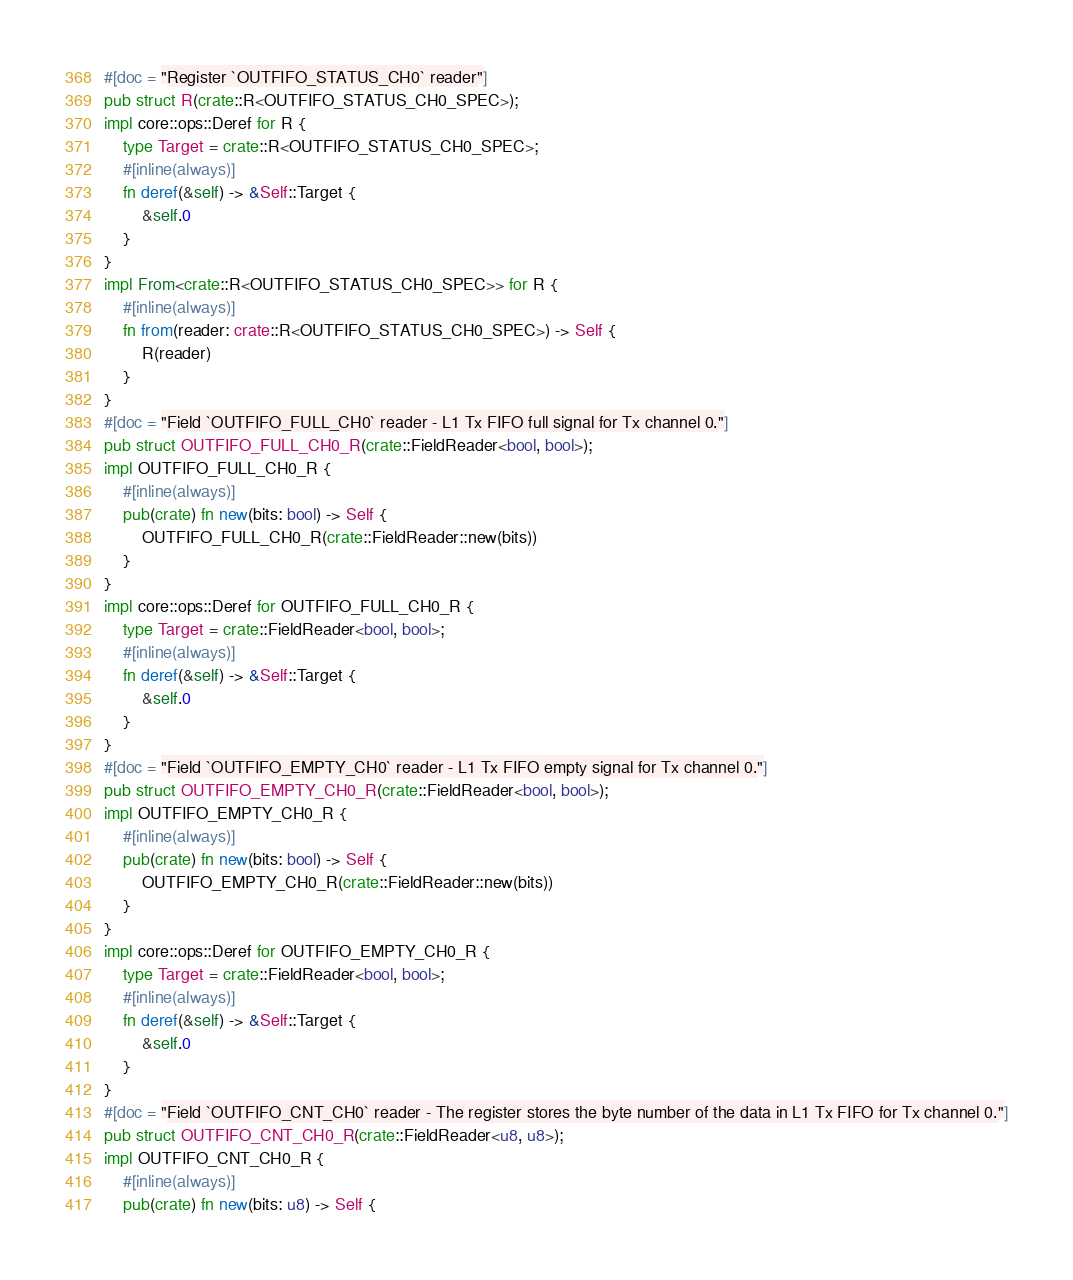Convert code to text. <code><loc_0><loc_0><loc_500><loc_500><_Rust_>#[doc = "Register `OUTFIFO_STATUS_CH0` reader"]
pub struct R(crate::R<OUTFIFO_STATUS_CH0_SPEC>);
impl core::ops::Deref for R {
    type Target = crate::R<OUTFIFO_STATUS_CH0_SPEC>;
    #[inline(always)]
    fn deref(&self) -> &Self::Target {
        &self.0
    }
}
impl From<crate::R<OUTFIFO_STATUS_CH0_SPEC>> for R {
    #[inline(always)]
    fn from(reader: crate::R<OUTFIFO_STATUS_CH0_SPEC>) -> Self {
        R(reader)
    }
}
#[doc = "Field `OUTFIFO_FULL_CH0` reader - L1 Tx FIFO full signal for Tx channel 0."]
pub struct OUTFIFO_FULL_CH0_R(crate::FieldReader<bool, bool>);
impl OUTFIFO_FULL_CH0_R {
    #[inline(always)]
    pub(crate) fn new(bits: bool) -> Self {
        OUTFIFO_FULL_CH0_R(crate::FieldReader::new(bits))
    }
}
impl core::ops::Deref for OUTFIFO_FULL_CH0_R {
    type Target = crate::FieldReader<bool, bool>;
    #[inline(always)]
    fn deref(&self) -> &Self::Target {
        &self.0
    }
}
#[doc = "Field `OUTFIFO_EMPTY_CH0` reader - L1 Tx FIFO empty signal for Tx channel 0."]
pub struct OUTFIFO_EMPTY_CH0_R(crate::FieldReader<bool, bool>);
impl OUTFIFO_EMPTY_CH0_R {
    #[inline(always)]
    pub(crate) fn new(bits: bool) -> Self {
        OUTFIFO_EMPTY_CH0_R(crate::FieldReader::new(bits))
    }
}
impl core::ops::Deref for OUTFIFO_EMPTY_CH0_R {
    type Target = crate::FieldReader<bool, bool>;
    #[inline(always)]
    fn deref(&self) -> &Self::Target {
        &self.0
    }
}
#[doc = "Field `OUTFIFO_CNT_CH0` reader - The register stores the byte number of the data in L1 Tx FIFO for Tx channel 0."]
pub struct OUTFIFO_CNT_CH0_R(crate::FieldReader<u8, u8>);
impl OUTFIFO_CNT_CH0_R {
    #[inline(always)]
    pub(crate) fn new(bits: u8) -> Self {</code> 